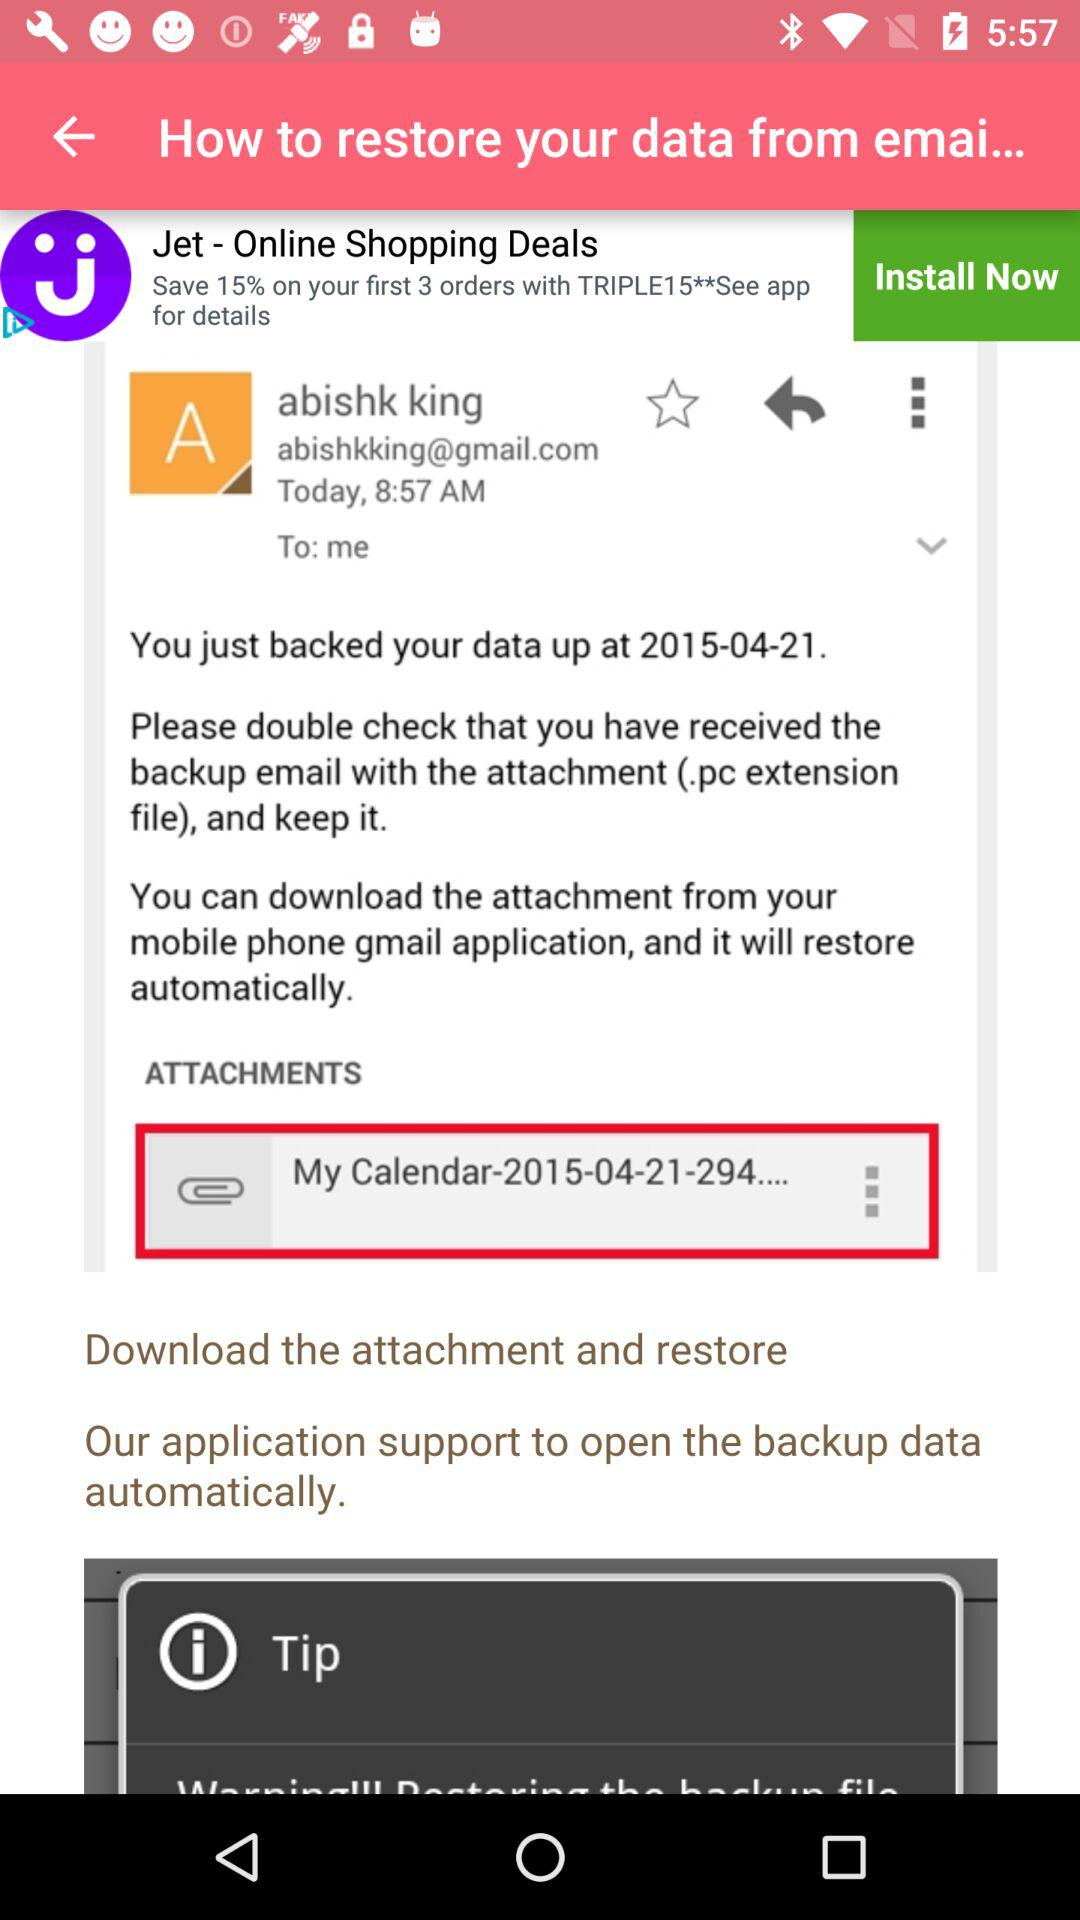What is the email address of Abishk King? The email address of Abishk King is abishkking@gmail.com. 